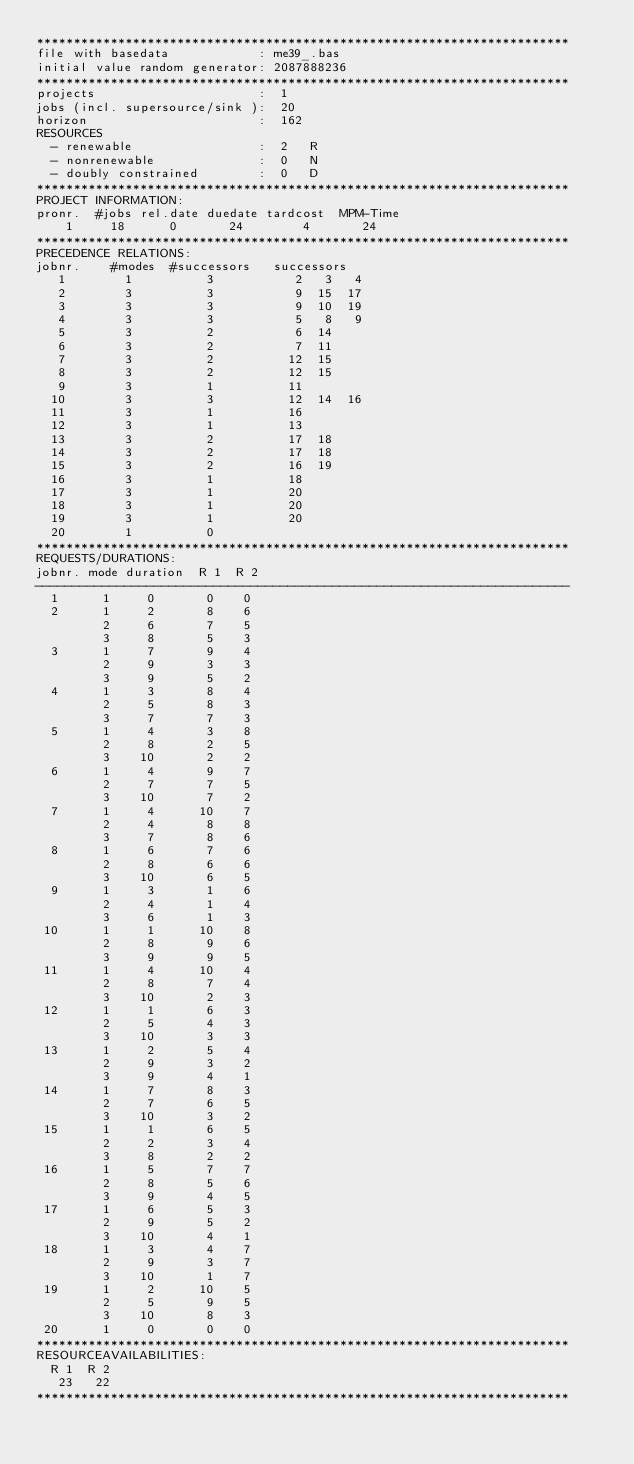<code> <loc_0><loc_0><loc_500><loc_500><_ObjectiveC_>************************************************************************
file with basedata            : me39_.bas
initial value random generator: 2087888236
************************************************************************
projects                      :  1
jobs (incl. supersource/sink ):  20
horizon                       :  162
RESOURCES
  - renewable                 :  2   R
  - nonrenewable              :  0   N
  - doubly constrained        :  0   D
************************************************************************
PROJECT INFORMATION:
pronr.  #jobs rel.date duedate tardcost  MPM-Time
    1     18      0       24        4       24
************************************************************************
PRECEDENCE RELATIONS:
jobnr.    #modes  #successors   successors
   1        1          3           2   3   4
   2        3          3           9  15  17
   3        3          3           9  10  19
   4        3          3           5   8   9
   5        3          2           6  14
   6        3          2           7  11
   7        3          2          12  15
   8        3          2          12  15
   9        3          1          11
  10        3          3          12  14  16
  11        3          1          16
  12        3          1          13
  13        3          2          17  18
  14        3          2          17  18
  15        3          2          16  19
  16        3          1          18
  17        3          1          20
  18        3          1          20
  19        3          1          20
  20        1          0        
************************************************************************
REQUESTS/DURATIONS:
jobnr. mode duration  R 1  R 2
------------------------------------------------------------------------
  1      1     0       0    0
  2      1     2       8    6
         2     6       7    5
         3     8       5    3
  3      1     7       9    4
         2     9       3    3
         3     9       5    2
  4      1     3       8    4
         2     5       8    3
         3     7       7    3
  5      1     4       3    8
         2     8       2    5
         3    10       2    2
  6      1     4       9    7
         2     7       7    5
         3    10       7    2
  7      1     4      10    7
         2     4       8    8
         3     7       8    6
  8      1     6       7    6
         2     8       6    6
         3    10       6    5
  9      1     3       1    6
         2     4       1    4
         3     6       1    3
 10      1     1      10    8
         2     8       9    6
         3     9       9    5
 11      1     4      10    4
         2     8       7    4
         3    10       2    3
 12      1     1       6    3
         2     5       4    3
         3    10       3    3
 13      1     2       5    4
         2     9       3    2
         3     9       4    1
 14      1     7       8    3
         2     7       6    5
         3    10       3    2
 15      1     1       6    5
         2     2       3    4
         3     8       2    2
 16      1     5       7    7
         2     8       5    6
         3     9       4    5
 17      1     6       5    3
         2     9       5    2
         3    10       4    1
 18      1     3       4    7
         2     9       3    7
         3    10       1    7
 19      1     2      10    5
         2     5       9    5
         3    10       8    3
 20      1     0       0    0
************************************************************************
RESOURCEAVAILABILITIES:
  R 1  R 2
   23   22
************************************************************************
</code> 